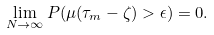Convert formula to latex. <formula><loc_0><loc_0><loc_500><loc_500>\lim _ { N \rightarrow \infty } P ( \mu ( \tau _ { m } - \zeta ) > \epsilon ) = 0 .</formula> 